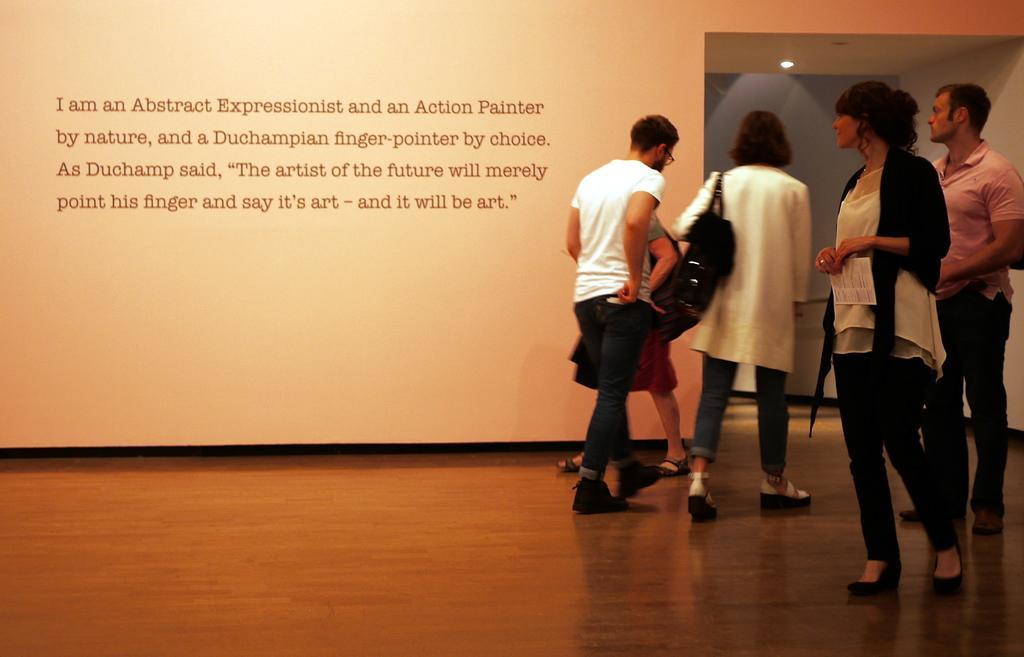Can you describe this image briefly? On the right side of the image there are people. Behind them there is a banner with some text on it. At the bottom of the image there is a floor. On top of the image there is a light. 